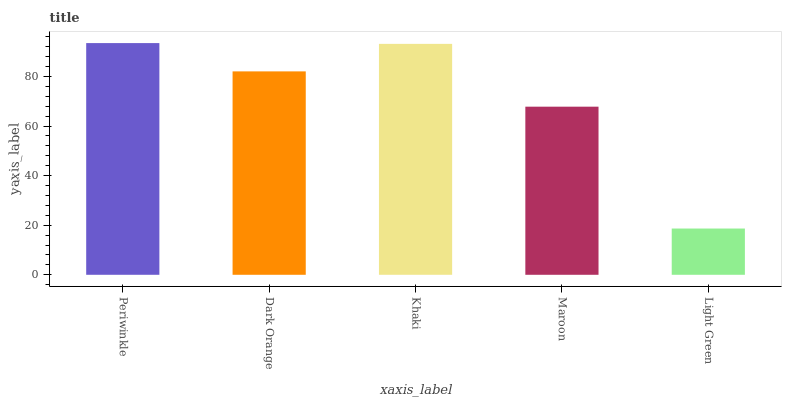Is Light Green the minimum?
Answer yes or no. Yes. Is Periwinkle the maximum?
Answer yes or no. Yes. Is Dark Orange the minimum?
Answer yes or no. No. Is Dark Orange the maximum?
Answer yes or no. No. Is Periwinkle greater than Dark Orange?
Answer yes or no. Yes. Is Dark Orange less than Periwinkle?
Answer yes or no. Yes. Is Dark Orange greater than Periwinkle?
Answer yes or no. No. Is Periwinkle less than Dark Orange?
Answer yes or no. No. Is Dark Orange the high median?
Answer yes or no. Yes. Is Dark Orange the low median?
Answer yes or no. Yes. Is Maroon the high median?
Answer yes or no. No. Is Periwinkle the low median?
Answer yes or no. No. 